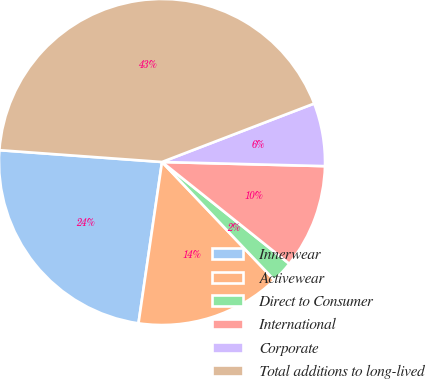Convert chart to OTSL. <chart><loc_0><loc_0><loc_500><loc_500><pie_chart><fcel>Innerwear<fcel>Activewear<fcel>Direct to Consumer<fcel>International<fcel>Corporate<fcel>Total additions to long-lived<nl><fcel>23.85%<fcel>14.41%<fcel>2.16%<fcel>10.33%<fcel>6.24%<fcel>43.01%<nl></chart> 